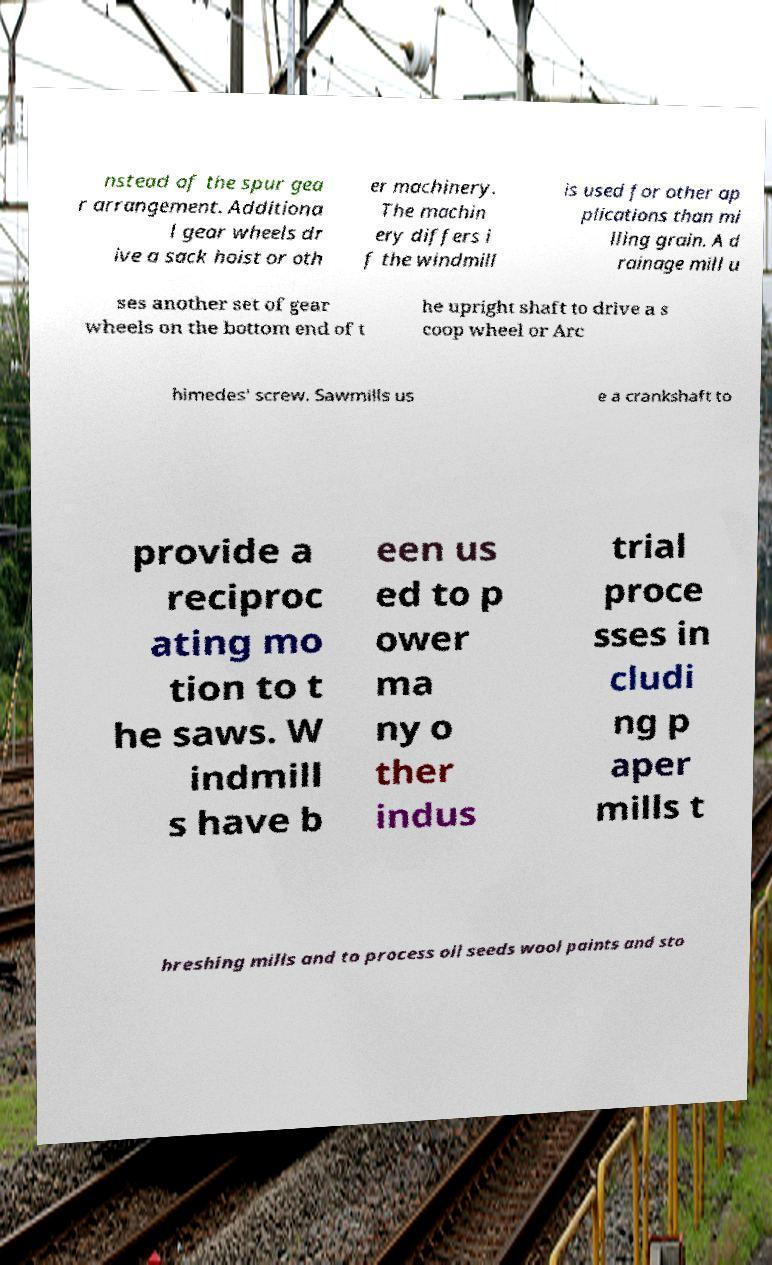For documentation purposes, I need the text within this image transcribed. Could you provide that? nstead of the spur gea r arrangement. Additiona l gear wheels dr ive a sack hoist or oth er machinery. The machin ery differs i f the windmill is used for other ap plications than mi lling grain. A d rainage mill u ses another set of gear wheels on the bottom end of t he upright shaft to drive a s coop wheel or Arc himedes' screw. Sawmills us e a crankshaft to provide a reciproc ating mo tion to t he saws. W indmill s have b een us ed to p ower ma ny o ther indus trial proce sses in cludi ng p aper mills t hreshing mills and to process oil seeds wool paints and sto 